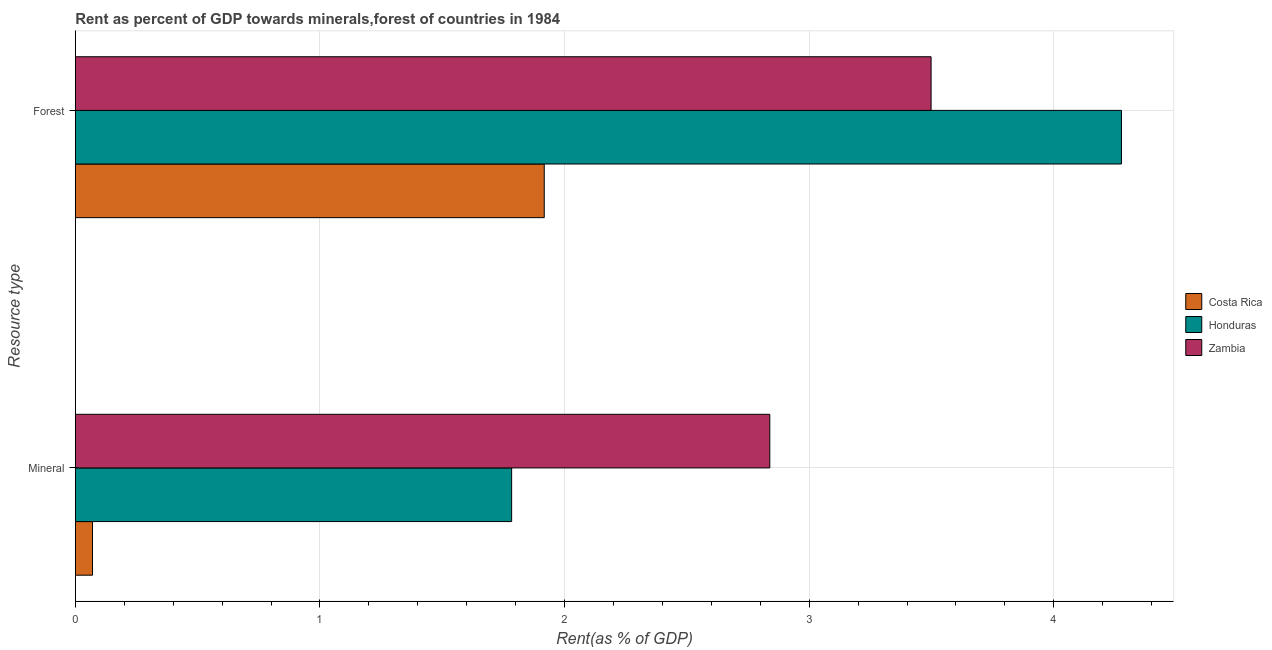How many groups of bars are there?
Give a very brief answer. 2. Are the number of bars per tick equal to the number of legend labels?
Offer a very short reply. Yes. Are the number of bars on each tick of the Y-axis equal?
Provide a succinct answer. Yes. How many bars are there on the 2nd tick from the top?
Offer a terse response. 3. How many bars are there on the 1st tick from the bottom?
Your response must be concise. 3. What is the label of the 2nd group of bars from the top?
Your answer should be very brief. Mineral. What is the mineral rent in Zambia?
Your answer should be compact. 2.84. Across all countries, what is the maximum forest rent?
Provide a short and direct response. 4.28. Across all countries, what is the minimum forest rent?
Your answer should be very brief. 1.92. In which country was the forest rent maximum?
Your answer should be very brief. Honduras. What is the total mineral rent in the graph?
Give a very brief answer. 4.69. What is the difference between the forest rent in Zambia and that in Honduras?
Ensure brevity in your answer.  -0.78. What is the difference between the forest rent in Honduras and the mineral rent in Costa Rica?
Offer a terse response. 4.21. What is the average forest rent per country?
Your answer should be very brief. 3.23. What is the difference between the forest rent and mineral rent in Zambia?
Offer a terse response. 0.66. What is the ratio of the mineral rent in Costa Rica to that in Honduras?
Provide a succinct answer. 0.04. Is the mineral rent in Zambia less than that in Costa Rica?
Your answer should be very brief. No. In how many countries, is the mineral rent greater than the average mineral rent taken over all countries?
Offer a very short reply. 2. What does the 1st bar from the top in Forest represents?
Your answer should be compact. Zambia. What does the 2nd bar from the bottom in Mineral represents?
Your answer should be very brief. Honduras. How many bars are there?
Give a very brief answer. 6. Are all the bars in the graph horizontal?
Provide a succinct answer. Yes. Does the graph contain grids?
Provide a succinct answer. Yes. How many legend labels are there?
Your response must be concise. 3. How are the legend labels stacked?
Your answer should be very brief. Vertical. What is the title of the graph?
Provide a short and direct response. Rent as percent of GDP towards minerals,forest of countries in 1984. Does "High income: OECD" appear as one of the legend labels in the graph?
Make the answer very short. No. What is the label or title of the X-axis?
Your answer should be very brief. Rent(as % of GDP). What is the label or title of the Y-axis?
Ensure brevity in your answer.  Resource type. What is the Rent(as % of GDP) in Costa Rica in Mineral?
Provide a short and direct response. 0.07. What is the Rent(as % of GDP) of Honduras in Mineral?
Provide a short and direct response. 1.78. What is the Rent(as % of GDP) of Zambia in Mineral?
Offer a terse response. 2.84. What is the Rent(as % of GDP) of Costa Rica in Forest?
Keep it short and to the point. 1.92. What is the Rent(as % of GDP) of Honduras in Forest?
Make the answer very short. 4.28. What is the Rent(as % of GDP) of Zambia in Forest?
Make the answer very short. 3.5. Across all Resource type, what is the maximum Rent(as % of GDP) in Costa Rica?
Offer a very short reply. 1.92. Across all Resource type, what is the maximum Rent(as % of GDP) in Honduras?
Your answer should be very brief. 4.28. Across all Resource type, what is the maximum Rent(as % of GDP) in Zambia?
Give a very brief answer. 3.5. Across all Resource type, what is the minimum Rent(as % of GDP) in Costa Rica?
Your answer should be very brief. 0.07. Across all Resource type, what is the minimum Rent(as % of GDP) in Honduras?
Provide a short and direct response. 1.78. Across all Resource type, what is the minimum Rent(as % of GDP) of Zambia?
Ensure brevity in your answer.  2.84. What is the total Rent(as % of GDP) in Costa Rica in the graph?
Provide a succinct answer. 1.99. What is the total Rent(as % of GDP) in Honduras in the graph?
Give a very brief answer. 6.06. What is the total Rent(as % of GDP) of Zambia in the graph?
Your answer should be very brief. 6.34. What is the difference between the Rent(as % of GDP) of Costa Rica in Mineral and that in Forest?
Keep it short and to the point. -1.85. What is the difference between the Rent(as % of GDP) of Honduras in Mineral and that in Forest?
Give a very brief answer. -2.49. What is the difference between the Rent(as % of GDP) in Zambia in Mineral and that in Forest?
Your answer should be compact. -0.66. What is the difference between the Rent(as % of GDP) in Costa Rica in Mineral and the Rent(as % of GDP) in Honduras in Forest?
Ensure brevity in your answer.  -4.21. What is the difference between the Rent(as % of GDP) of Costa Rica in Mineral and the Rent(as % of GDP) of Zambia in Forest?
Make the answer very short. -3.43. What is the difference between the Rent(as % of GDP) of Honduras in Mineral and the Rent(as % of GDP) of Zambia in Forest?
Give a very brief answer. -1.71. What is the average Rent(as % of GDP) of Honduras per Resource type?
Provide a short and direct response. 3.03. What is the average Rent(as % of GDP) in Zambia per Resource type?
Your response must be concise. 3.17. What is the difference between the Rent(as % of GDP) of Costa Rica and Rent(as % of GDP) of Honduras in Mineral?
Keep it short and to the point. -1.71. What is the difference between the Rent(as % of GDP) in Costa Rica and Rent(as % of GDP) in Zambia in Mineral?
Make the answer very short. -2.77. What is the difference between the Rent(as % of GDP) in Honduras and Rent(as % of GDP) in Zambia in Mineral?
Your response must be concise. -1.06. What is the difference between the Rent(as % of GDP) of Costa Rica and Rent(as % of GDP) of Honduras in Forest?
Offer a very short reply. -2.36. What is the difference between the Rent(as % of GDP) of Costa Rica and Rent(as % of GDP) of Zambia in Forest?
Offer a terse response. -1.58. What is the difference between the Rent(as % of GDP) in Honduras and Rent(as % of GDP) in Zambia in Forest?
Make the answer very short. 0.78. What is the ratio of the Rent(as % of GDP) in Costa Rica in Mineral to that in Forest?
Keep it short and to the point. 0.04. What is the ratio of the Rent(as % of GDP) of Honduras in Mineral to that in Forest?
Make the answer very short. 0.42. What is the ratio of the Rent(as % of GDP) in Zambia in Mineral to that in Forest?
Offer a terse response. 0.81. What is the difference between the highest and the second highest Rent(as % of GDP) of Costa Rica?
Offer a very short reply. 1.85. What is the difference between the highest and the second highest Rent(as % of GDP) in Honduras?
Provide a succinct answer. 2.49. What is the difference between the highest and the second highest Rent(as % of GDP) of Zambia?
Give a very brief answer. 0.66. What is the difference between the highest and the lowest Rent(as % of GDP) of Costa Rica?
Make the answer very short. 1.85. What is the difference between the highest and the lowest Rent(as % of GDP) of Honduras?
Ensure brevity in your answer.  2.49. What is the difference between the highest and the lowest Rent(as % of GDP) in Zambia?
Ensure brevity in your answer.  0.66. 